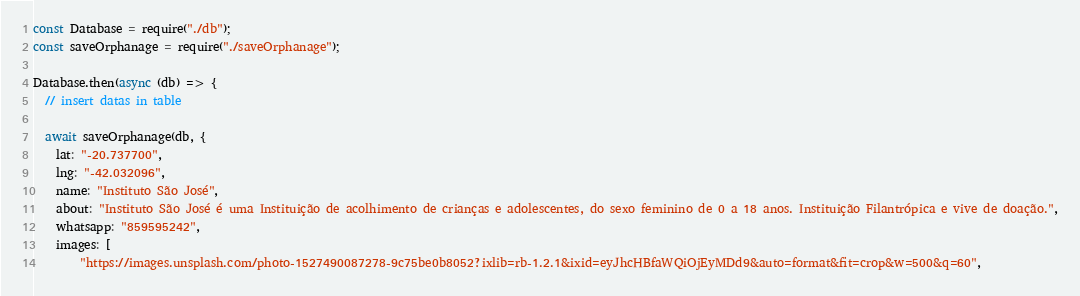<code> <loc_0><loc_0><loc_500><loc_500><_JavaScript_>const Database = require("./db");
const saveOrphanage = require("./saveOrphanage");

Database.then(async (db) => {
  // insert datas in table

  await saveOrphanage(db, {
    lat: "-20.737700",
    lng: "-42.032096", 
    name: "Instituto São José",
    about: "Instituto São José é uma Instituição de acolhimento de crianças e adolescentes, do sexo feminino de 0 a 18 anos. Instituição Filantrópica e vive de doação.",
    whatsapp: "859595242",
    images: [
        "https://images.unsplash.com/photo-1527490087278-9c75be0b8052?ixlib=rb-1.2.1&ixid=eyJhcHBfaWQiOjEyMDd9&auto=format&fit=crop&w=500&q=60",</code> 